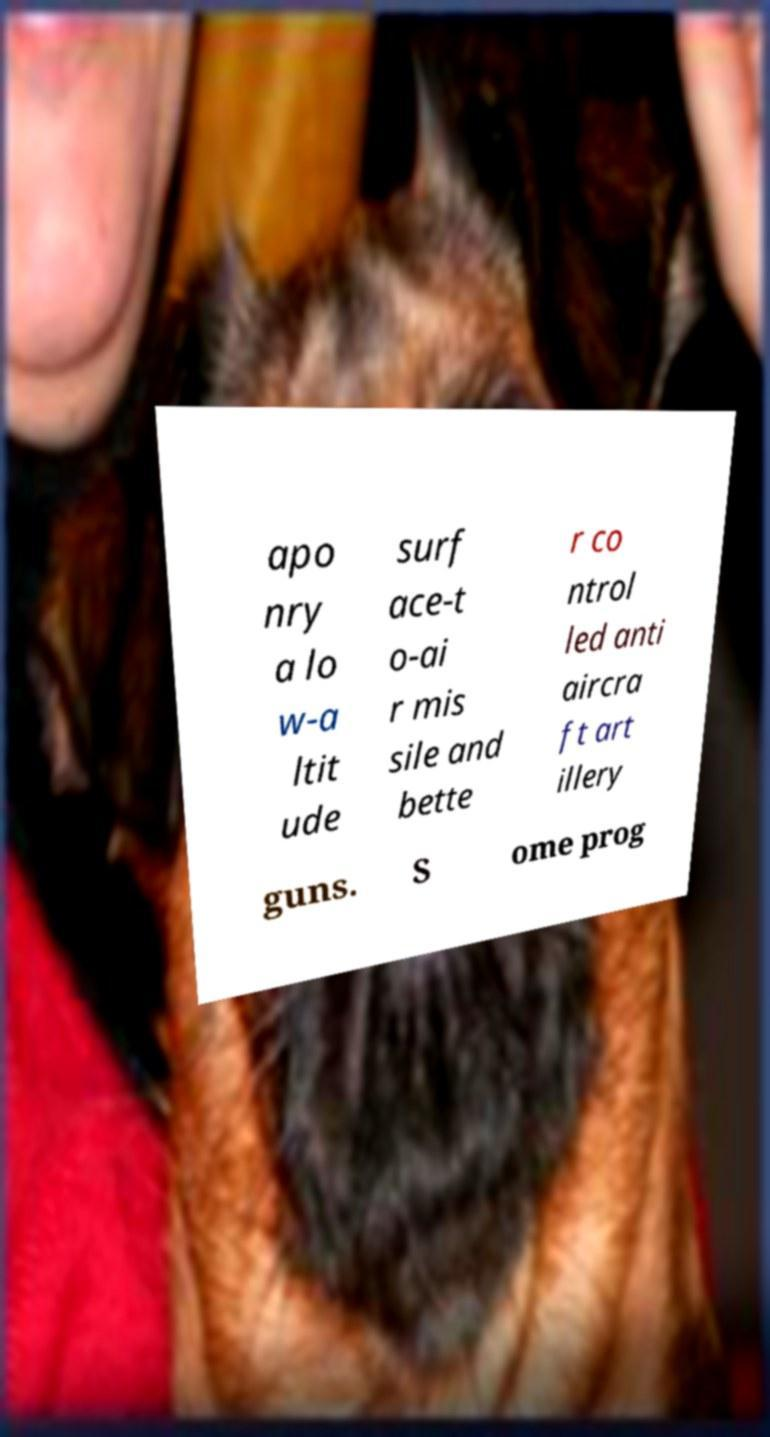There's text embedded in this image that I need extracted. Can you transcribe it verbatim? apo nry a lo w-a ltit ude surf ace-t o-ai r mis sile and bette r co ntrol led anti aircra ft art illery guns. S ome prog 